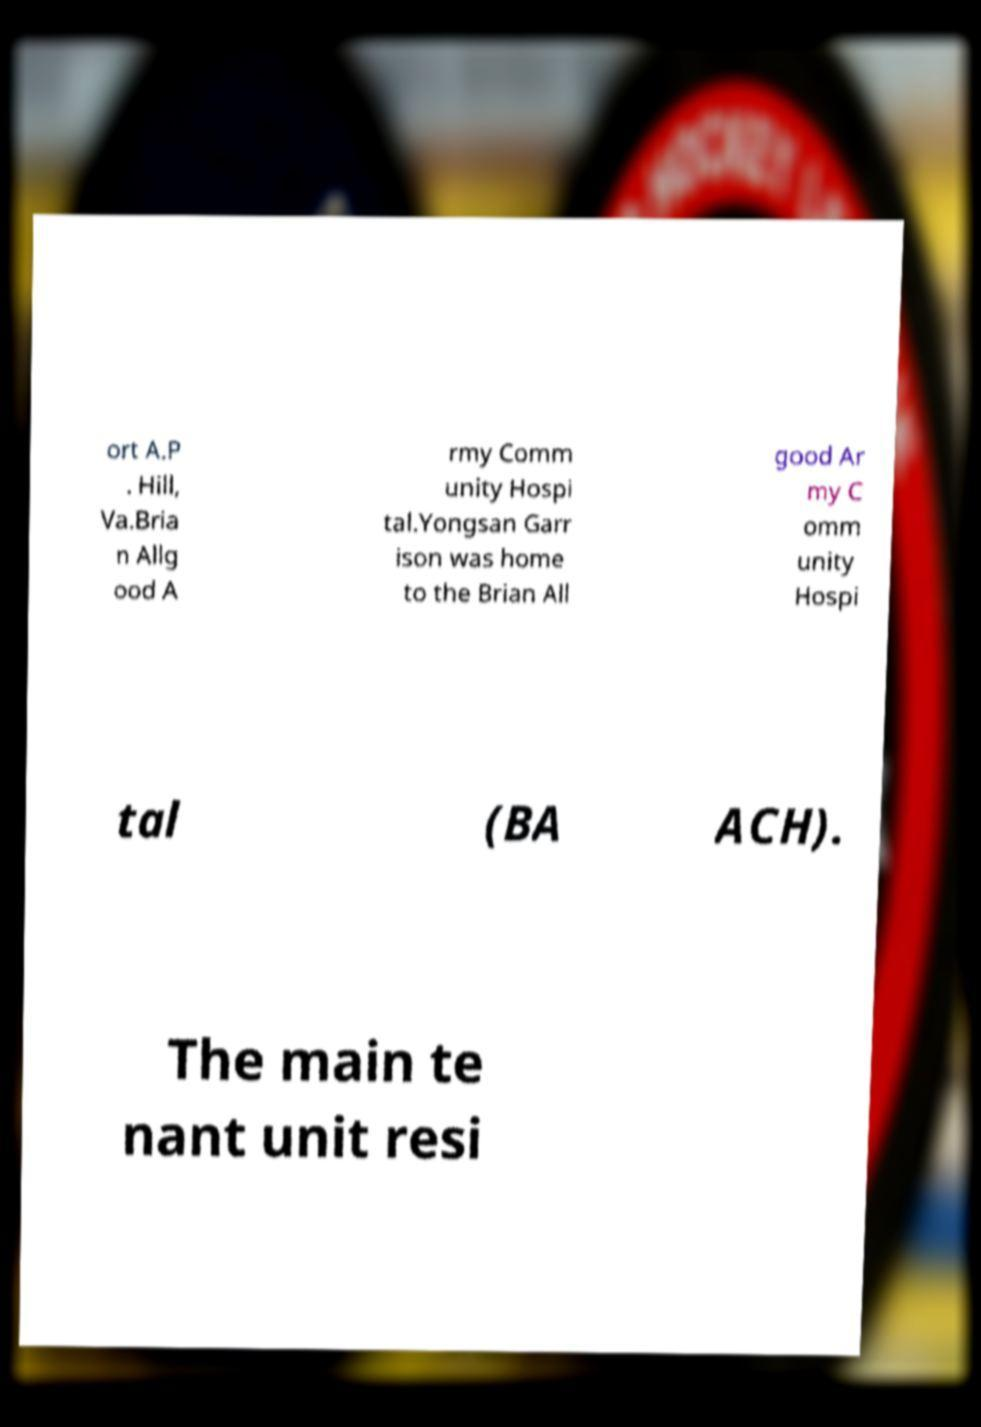Please read and relay the text visible in this image. What does it say? ort A.P . Hill, Va.Bria n Allg ood A rmy Comm unity Hospi tal.Yongsan Garr ison was home to the Brian All good Ar my C omm unity Hospi tal (BA ACH). The main te nant unit resi 